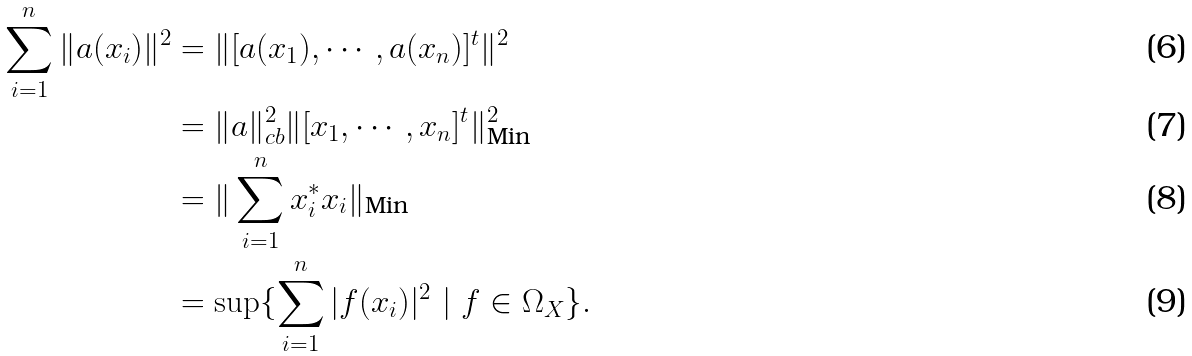<formula> <loc_0><loc_0><loc_500><loc_500>\sum _ { i = 1 } ^ { n } \| a ( x _ { i } ) \| ^ { 2 } & = \| [ a ( x _ { 1 } ) , \cdots , a ( x _ { n } ) ] ^ { t } \| ^ { 2 } \\ & = \| a \| _ { c b } ^ { 2 } \| [ x _ { 1 } , \cdots , x _ { n } ] ^ { t } \| ^ { 2 } _ { \text {Min} } \\ & = \| \sum _ { i = 1 } ^ { n } x _ { i } ^ { * } x _ { i } \| _ { \text {Min} } \\ & = \sup \{ \sum _ { i = 1 } ^ { n } | f ( x _ { i } ) | ^ { 2 } \ | \ f \in \Omega _ { X } \} .</formula> 